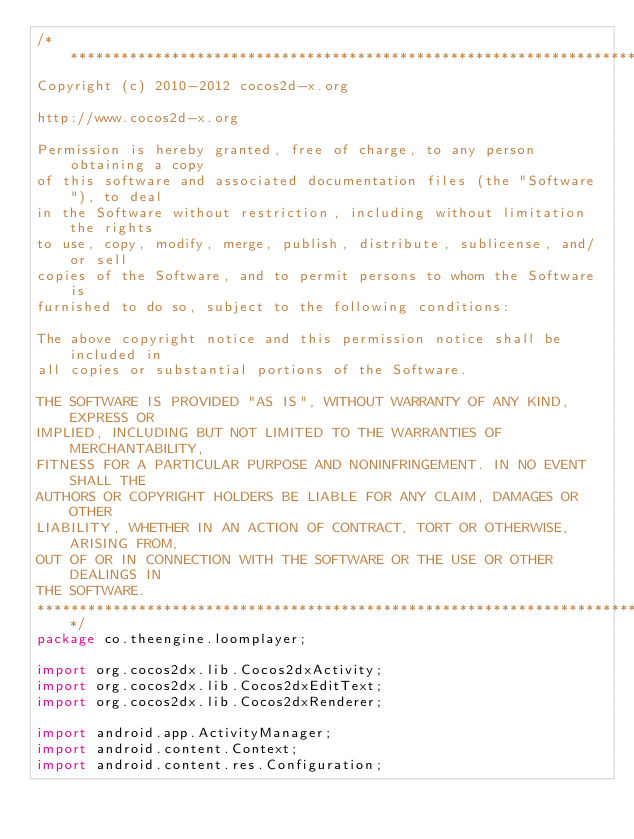<code> <loc_0><loc_0><loc_500><loc_500><_Java_>/****************************************************************************
Copyright (c) 2010-2012 cocos2d-x.org

http://www.cocos2d-x.org

Permission is hereby granted, free of charge, to any person obtaining a copy
of this software and associated documentation files (the "Software"), to deal
in the Software without restriction, including without limitation the rights
to use, copy, modify, merge, publish, distribute, sublicense, and/or sell
copies of the Software, and to permit persons to whom the Software is
furnished to do so, subject to the following conditions:

The above copyright notice and this permission notice shall be included in
all copies or substantial portions of the Software.

THE SOFTWARE IS PROVIDED "AS IS", WITHOUT WARRANTY OF ANY KIND, EXPRESS OR
IMPLIED, INCLUDING BUT NOT LIMITED TO THE WARRANTIES OF MERCHANTABILITY,
FITNESS FOR A PARTICULAR PURPOSE AND NONINFRINGEMENT. IN NO EVENT SHALL THE
AUTHORS OR COPYRIGHT HOLDERS BE LIABLE FOR ANY CLAIM, DAMAGES OR OTHER
LIABILITY, WHETHER IN AN ACTION OF CONTRACT, TORT OR OTHERWISE, ARISING FROM,
OUT OF OR IN CONNECTION WITH THE SOFTWARE OR THE USE OR OTHER DEALINGS IN
THE SOFTWARE.
****************************************************************************/
package co.theengine.loomplayer;

import org.cocos2dx.lib.Cocos2dxActivity;
import org.cocos2dx.lib.Cocos2dxEditText;
import org.cocos2dx.lib.Cocos2dxRenderer;

import android.app.ActivityManager;
import android.content.Context;
import android.content.res.Configuration;</code> 